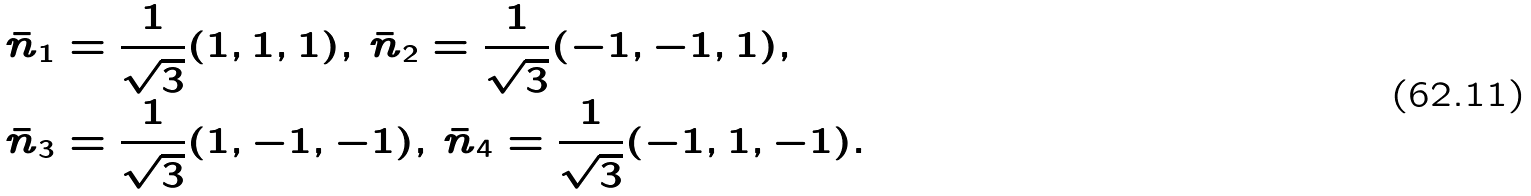<formula> <loc_0><loc_0><loc_500><loc_500>\bar { n } _ { 1 } & = \frac { 1 } { \sqrt { 3 } } ( 1 , 1 , 1 ) , \, \bar { n } _ { 2 } = \frac { 1 } { \sqrt { 3 } } ( - 1 , - 1 , 1 ) , \\ \bar { n } _ { 3 } & = \frac { 1 } { \sqrt { 3 } } ( 1 , - 1 , - 1 ) , \, \bar { n } _ { 4 } = \frac { 1 } { \sqrt { 3 } } ( - 1 , 1 , - 1 ) .</formula> 